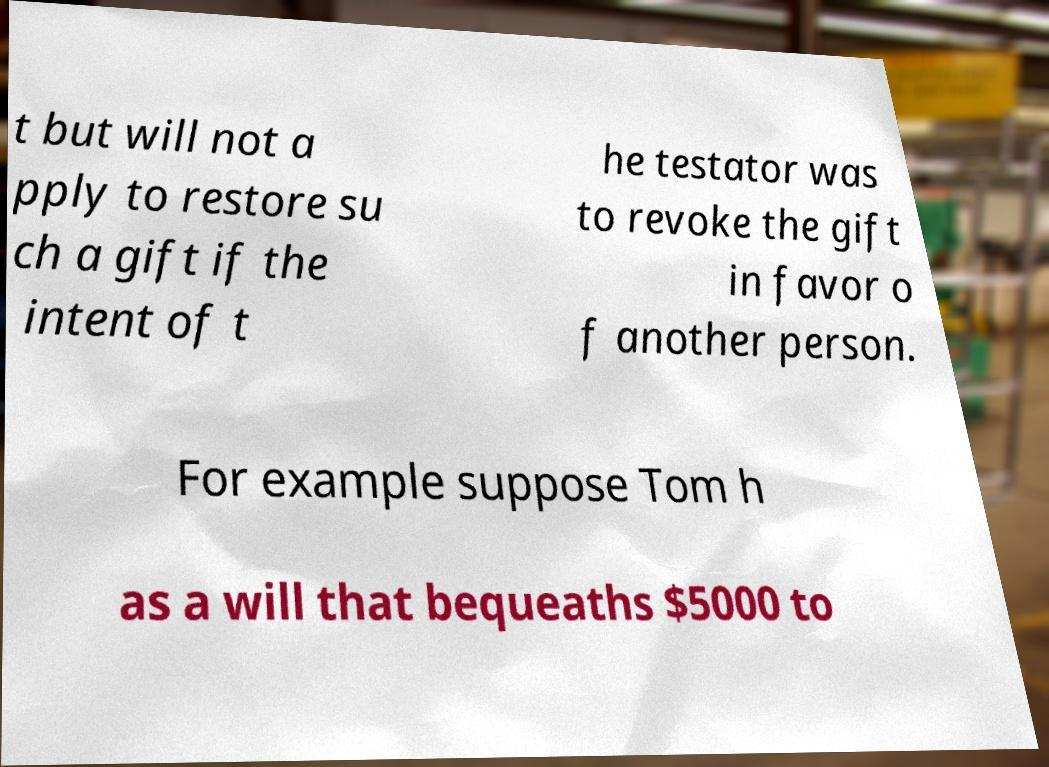Could you extract and type out the text from this image? t but will not a pply to restore su ch a gift if the intent of t he testator was to revoke the gift in favor o f another person. For example suppose Tom h as a will that bequeaths $5000 to 